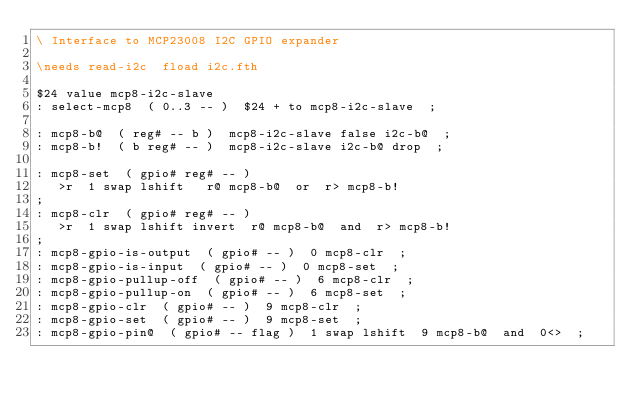Convert code to text. <code><loc_0><loc_0><loc_500><loc_500><_Forth_>\ Interface to MCP23008 I2C GPIO expander

\needs read-i2c  fload i2c.fth

$24 value mcp8-i2c-slave
: select-mcp8  ( 0..3 -- )  $24 + to mcp8-i2c-slave  ;

: mcp8-b@  ( reg# -- b )  mcp8-i2c-slave false i2c-b@  ;
: mcp8-b!  ( b reg# -- )  mcp8-i2c-slave i2c-b@ drop  ;

: mcp8-set  ( gpio# reg# -- )
   >r  1 swap lshift   r@ mcp8-b@  or  r> mcp8-b!
;
: mcp8-clr  ( gpio# reg# -- )
   >r  1 swap lshift invert  r@ mcp8-b@  and  r> mcp8-b!
;
: mcp8-gpio-is-output  ( gpio# -- )  0 mcp8-clr  ;
: mcp8-gpio-is-input  ( gpio# -- )  0 mcp8-set  ;
: mcp8-gpio-pullup-off  ( gpio# -- )  6 mcp8-clr  ;
: mcp8-gpio-pullup-on  ( gpio# -- )  6 mcp8-set  ;
: mcp8-gpio-clr  ( gpio# -- )  9 mcp8-clr  ;
: mcp8-gpio-set  ( gpio# -- )  9 mcp8-set  ;
: mcp8-gpio-pin@  ( gpio# -- flag )  1 swap lshift  9 mcp8-b@  and  0<>  ;
</code> 